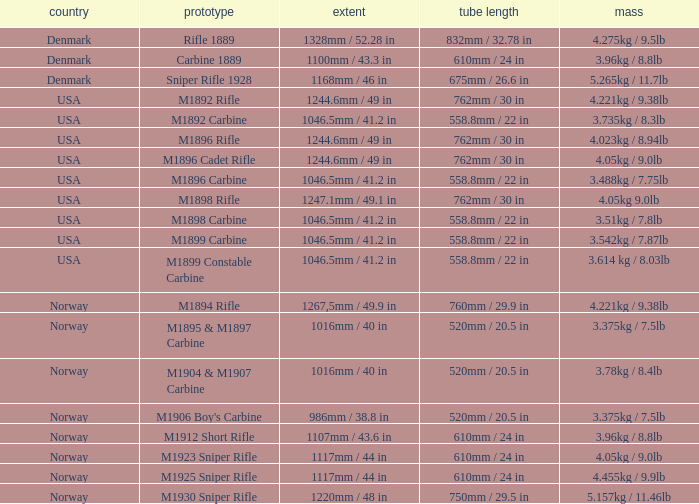What is Weight, when Length is 1168mm / 46 in? 5.265kg / 11.7lb. 